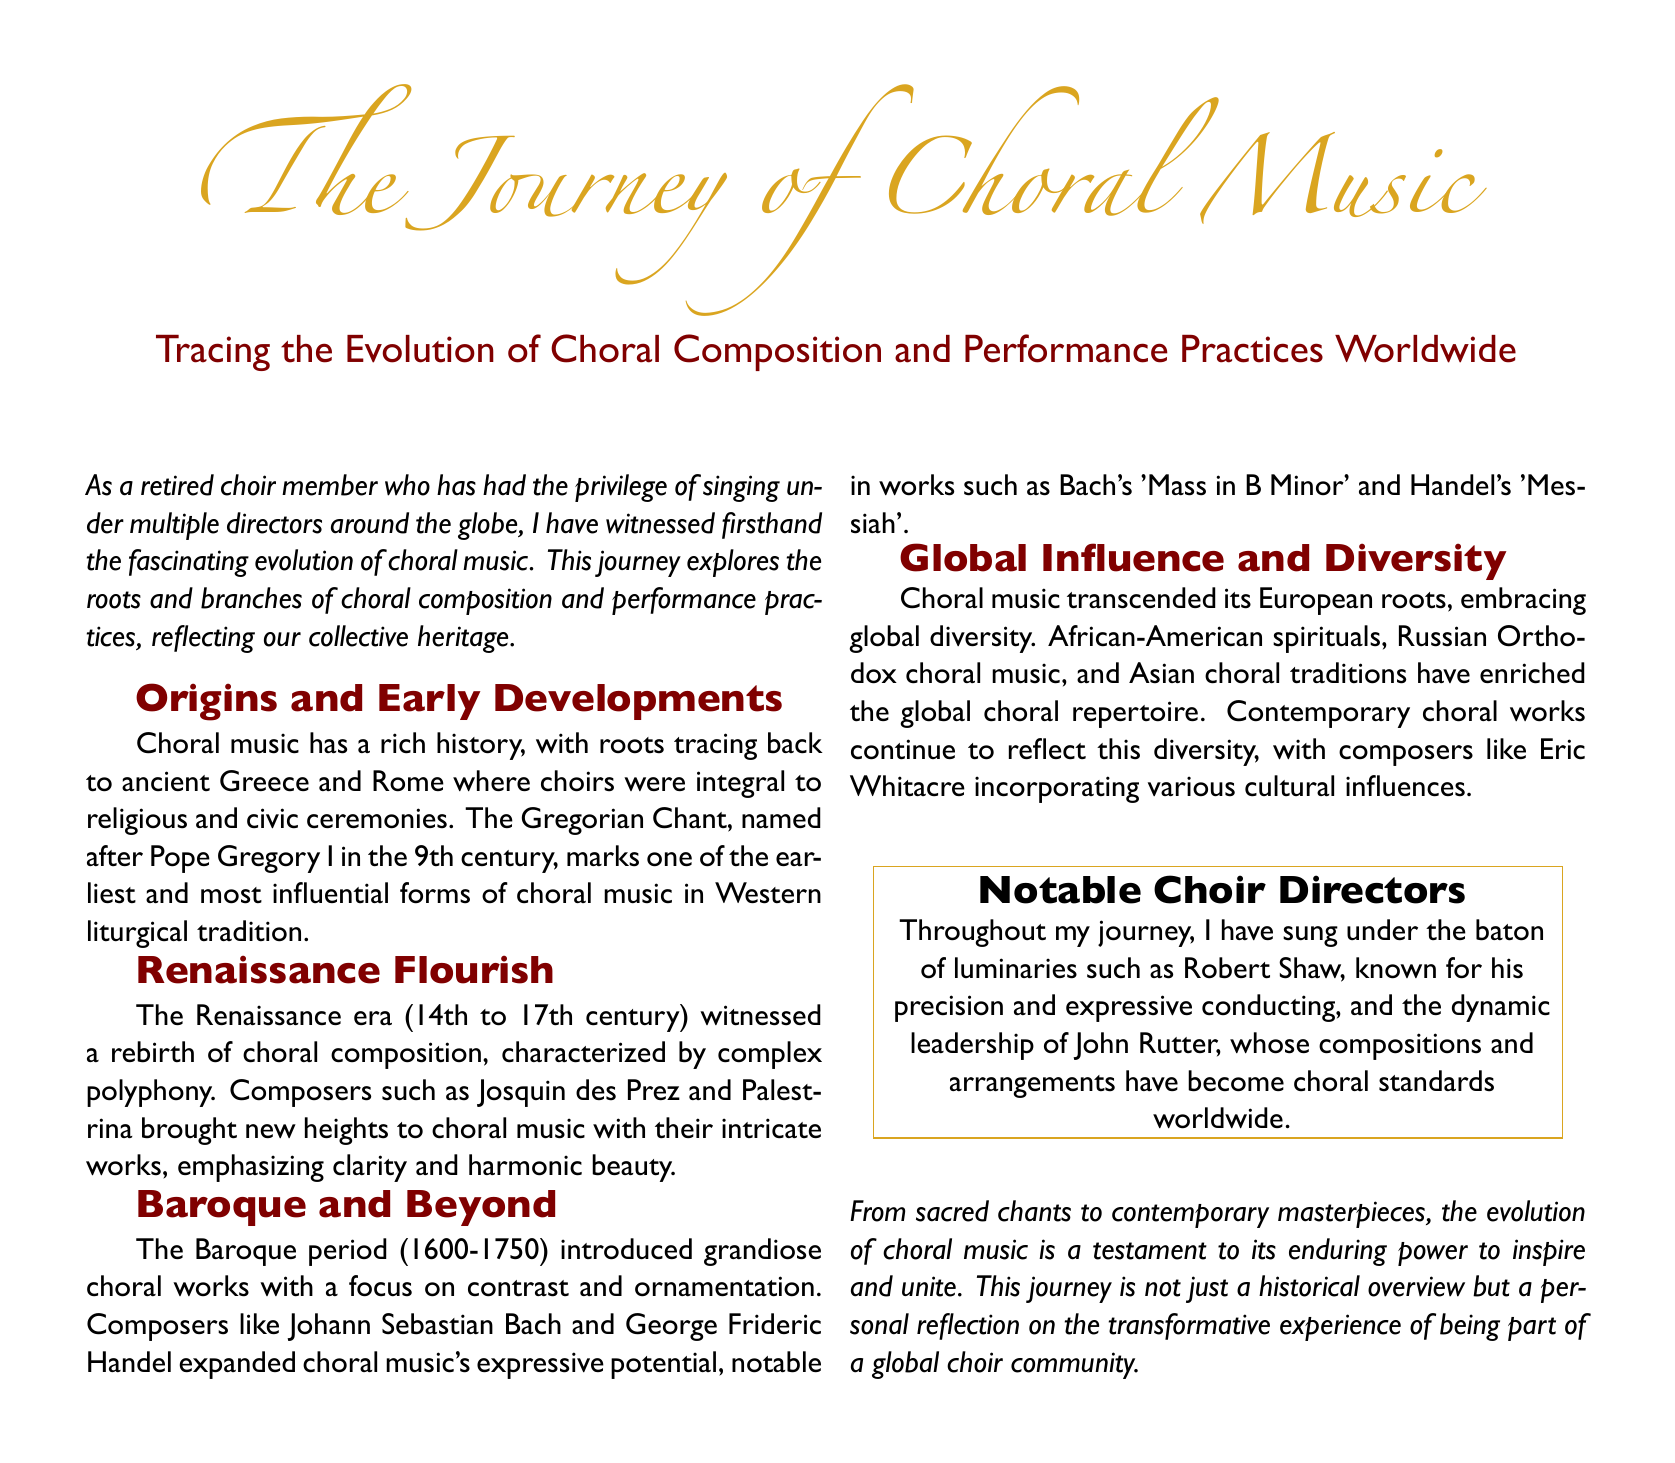What are the roots of choral music? The document states that choral music has roots tracing back to ancient Greece and Rome.
Answer: ancient Greece and Rome Who composed 'Messiah'? The document mentions George Frideric Handel as the composer of 'Messiah'.
Answer: George Frideric Handel What era is known for complex polyphony? The Renaissance era is characterized by complex polyphony according to the document.
Answer: Renaissance era Which choral work is associated with Johann Sebastian Bach? The document cites Bach's 'Mass in B Minor' as a notable work.
Answer: Mass in B Minor Name a notable choir director mentioned in the document. The document includes Robert Shaw as a notable choir director.
Answer: Robert Shaw What significant choral traditions does the document mention? The document references African-American spirituals, Russian Orthodox choral music, and Asian choral traditions.
Answer: African-American spirituals, Russian Orthodox choral music, Asian choral traditions What is the overarching theme of the document? The document reflects on the evolution and transformative experiences of choral music.
Answer: evolution and transformative experiences During which period did the Baroque style emerge? The document states the Baroque period lasted from 1600 to 1750.
Answer: 1600-1750 